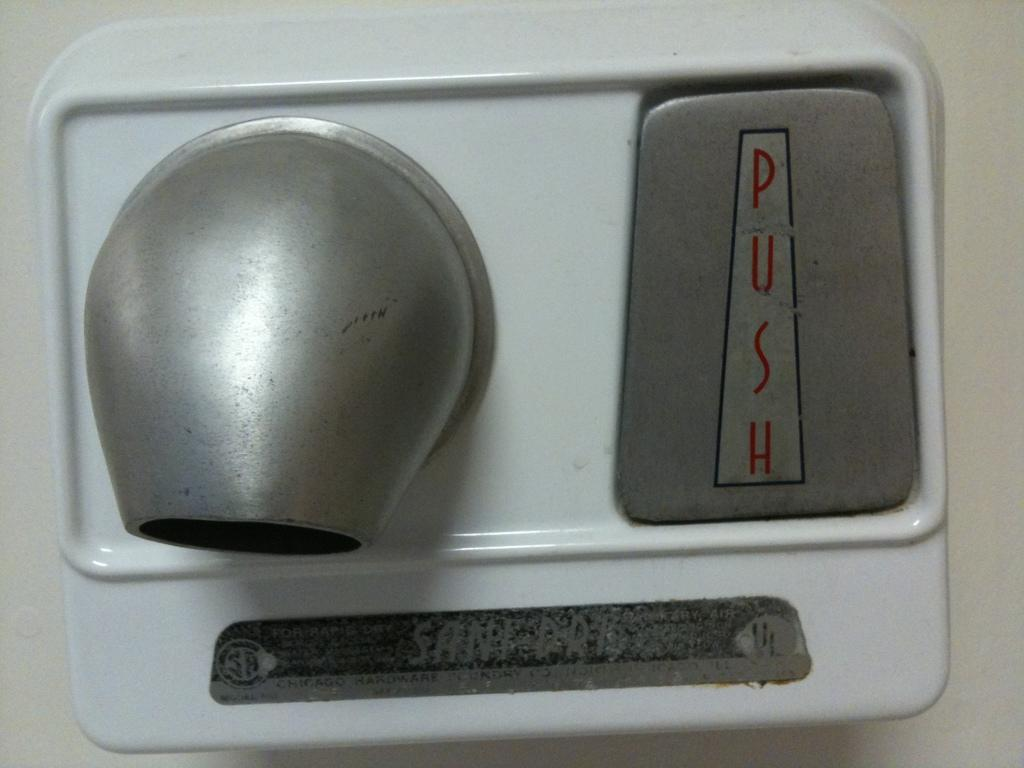<image>
Offer a succinct explanation of the picture presented. Drying machine that says PUSH in red letters. 